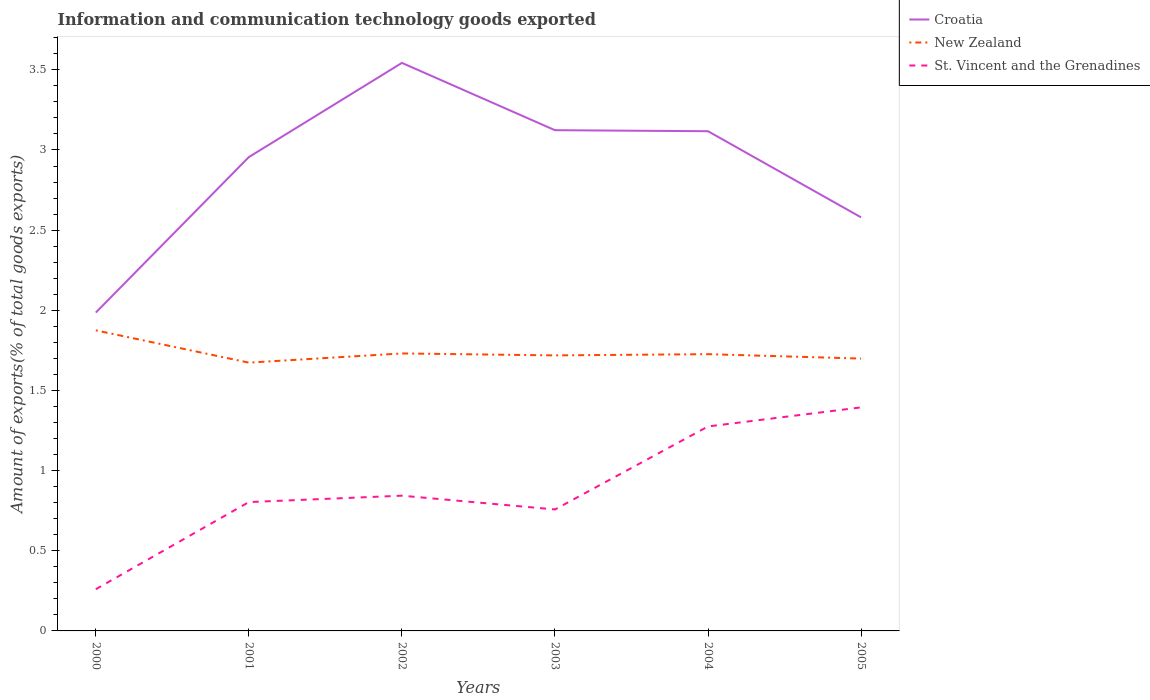How many different coloured lines are there?
Your response must be concise. 3. Is the number of lines equal to the number of legend labels?
Keep it short and to the point. Yes. Across all years, what is the maximum amount of goods exported in Croatia?
Provide a succinct answer. 1.99. In which year was the amount of goods exported in Croatia maximum?
Your response must be concise. 2000. What is the total amount of goods exported in New Zealand in the graph?
Your answer should be compact. 0.03. What is the difference between the highest and the second highest amount of goods exported in New Zealand?
Keep it short and to the point. 0.2. What is the difference between the highest and the lowest amount of goods exported in Croatia?
Give a very brief answer. 4. Is the amount of goods exported in St. Vincent and the Grenadines strictly greater than the amount of goods exported in New Zealand over the years?
Give a very brief answer. Yes. How many years are there in the graph?
Give a very brief answer. 6. Does the graph contain any zero values?
Your response must be concise. No. Does the graph contain grids?
Provide a succinct answer. No. Where does the legend appear in the graph?
Offer a terse response. Top right. How many legend labels are there?
Provide a succinct answer. 3. What is the title of the graph?
Your answer should be very brief. Information and communication technology goods exported. Does "Armenia" appear as one of the legend labels in the graph?
Your answer should be very brief. No. What is the label or title of the Y-axis?
Ensure brevity in your answer.  Amount of exports(% of total goods exports). What is the Amount of exports(% of total goods exports) in Croatia in 2000?
Your answer should be compact. 1.99. What is the Amount of exports(% of total goods exports) of New Zealand in 2000?
Give a very brief answer. 1.87. What is the Amount of exports(% of total goods exports) of St. Vincent and the Grenadines in 2000?
Offer a terse response. 0.26. What is the Amount of exports(% of total goods exports) in Croatia in 2001?
Your answer should be compact. 2.96. What is the Amount of exports(% of total goods exports) of New Zealand in 2001?
Provide a succinct answer. 1.67. What is the Amount of exports(% of total goods exports) in St. Vincent and the Grenadines in 2001?
Give a very brief answer. 0.8. What is the Amount of exports(% of total goods exports) in Croatia in 2002?
Offer a very short reply. 3.54. What is the Amount of exports(% of total goods exports) in New Zealand in 2002?
Ensure brevity in your answer.  1.73. What is the Amount of exports(% of total goods exports) in St. Vincent and the Grenadines in 2002?
Your response must be concise. 0.84. What is the Amount of exports(% of total goods exports) of Croatia in 2003?
Provide a succinct answer. 3.12. What is the Amount of exports(% of total goods exports) in New Zealand in 2003?
Make the answer very short. 1.72. What is the Amount of exports(% of total goods exports) of St. Vincent and the Grenadines in 2003?
Provide a succinct answer. 0.76. What is the Amount of exports(% of total goods exports) of Croatia in 2004?
Ensure brevity in your answer.  3.12. What is the Amount of exports(% of total goods exports) in New Zealand in 2004?
Ensure brevity in your answer.  1.73. What is the Amount of exports(% of total goods exports) in St. Vincent and the Grenadines in 2004?
Make the answer very short. 1.28. What is the Amount of exports(% of total goods exports) in Croatia in 2005?
Your answer should be compact. 2.58. What is the Amount of exports(% of total goods exports) of New Zealand in 2005?
Your answer should be compact. 1.7. What is the Amount of exports(% of total goods exports) of St. Vincent and the Grenadines in 2005?
Your answer should be compact. 1.39. Across all years, what is the maximum Amount of exports(% of total goods exports) of Croatia?
Keep it short and to the point. 3.54. Across all years, what is the maximum Amount of exports(% of total goods exports) of New Zealand?
Your response must be concise. 1.87. Across all years, what is the maximum Amount of exports(% of total goods exports) in St. Vincent and the Grenadines?
Give a very brief answer. 1.39. Across all years, what is the minimum Amount of exports(% of total goods exports) of Croatia?
Your response must be concise. 1.99. Across all years, what is the minimum Amount of exports(% of total goods exports) of New Zealand?
Offer a terse response. 1.67. Across all years, what is the minimum Amount of exports(% of total goods exports) of St. Vincent and the Grenadines?
Your answer should be compact. 0.26. What is the total Amount of exports(% of total goods exports) in Croatia in the graph?
Offer a very short reply. 17.31. What is the total Amount of exports(% of total goods exports) of New Zealand in the graph?
Ensure brevity in your answer.  10.42. What is the total Amount of exports(% of total goods exports) in St. Vincent and the Grenadines in the graph?
Offer a very short reply. 5.34. What is the difference between the Amount of exports(% of total goods exports) in Croatia in 2000 and that in 2001?
Keep it short and to the point. -0.97. What is the difference between the Amount of exports(% of total goods exports) of New Zealand in 2000 and that in 2001?
Provide a short and direct response. 0.2. What is the difference between the Amount of exports(% of total goods exports) in St. Vincent and the Grenadines in 2000 and that in 2001?
Make the answer very short. -0.54. What is the difference between the Amount of exports(% of total goods exports) in Croatia in 2000 and that in 2002?
Your response must be concise. -1.56. What is the difference between the Amount of exports(% of total goods exports) in New Zealand in 2000 and that in 2002?
Keep it short and to the point. 0.14. What is the difference between the Amount of exports(% of total goods exports) of St. Vincent and the Grenadines in 2000 and that in 2002?
Provide a succinct answer. -0.58. What is the difference between the Amount of exports(% of total goods exports) of Croatia in 2000 and that in 2003?
Ensure brevity in your answer.  -1.14. What is the difference between the Amount of exports(% of total goods exports) in New Zealand in 2000 and that in 2003?
Provide a succinct answer. 0.16. What is the difference between the Amount of exports(% of total goods exports) of St. Vincent and the Grenadines in 2000 and that in 2003?
Offer a terse response. -0.5. What is the difference between the Amount of exports(% of total goods exports) in Croatia in 2000 and that in 2004?
Provide a short and direct response. -1.13. What is the difference between the Amount of exports(% of total goods exports) of New Zealand in 2000 and that in 2004?
Offer a very short reply. 0.15. What is the difference between the Amount of exports(% of total goods exports) in St. Vincent and the Grenadines in 2000 and that in 2004?
Give a very brief answer. -1.02. What is the difference between the Amount of exports(% of total goods exports) of Croatia in 2000 and that in 2005?
Keep it short and to the point. -0.59. What is the difference between the Amount of exports(% of total goods exports) of New Zealand in 2000 and that in 2005?
Keep it short and to the point. 0.18. What is the difference between the Amount of exports(% of total goods exports) of St. Vincent and the Grenadines in 2000 and that in 2005?
Your response must be concise. -1.13. What is the difference between the Amount of exports(% of total goods exports) in Croatia in 2001 and that in 2002?
Ensure brevity in your answer.  -0.59. What is the difference between the Amount of exports(% of total goods exports) of New Zealand in 2001 and that in 2002?
Give a very brief answer. -0.06. What is the difference between the Amount of exports(% of total goods exports) of St. Vincent and the Grenadines in 2001 and that in 2002?
Offer a terse response. -0.04. What is the difference between the Amount of exports(% of total goods exports) of Croatia in 2001 and that in 2003?
Provide a succinct answer. -0.17. What is the difference between the Amount of exports(% of total goods exports) in New Zealand in 2001 and that in 2003?
Keep it short and to the point. -0.05. What is the difference between the Amount of exports(% of total goods exports) of St. Vincent and the Grenadines in 2001 and that in 2003?
Offer a very short reply. 0.05. What is the difference between the Amount of exports(% of total goods exports) in Croatia in 2001 and that in 2004?
Your response must be concise. -0.16. What is the difference between the Amount of exports(% of total goods exports) in New Zealand in 2001 and that in 2004?
Give a very brief answer. -0.05. What is the difference between the Amount of exports(% of total goods exports) of St. Vincent and the Grenadines in 2001 and that in 2004?
Ensure brevity in your answer.  -0.47. What is the difference between the Amount of exports(% of total goods exports) of Croatia in 2001 and that in 2005?
Ensure brevity in your answer.  0.38. What is the difference between the Amount of exports(% of total goods exports) in New Zealand in 2001 and that in 2005?
Keep it short and to the point. -0.03. What is the difference between the Amount of exports(% of total goods exports) of St. Vincent and the Grenadines in 2001 and that in 2005?
Give a very brief answer. -0.59. What is the difference between the Amount of exports(% of total goods exports) in Croatia in 2002 and that in 2003?
Provide a succinct answer. 0.42. What is the difference between the Amount of exports(% of total goods exports) in New Zealand in 2002 and that in 2003?
Your answer should be compact. 0.01. What is the difference between the Amount of exports(% of total goods exports) in St. Vincent and the Grenadines in 2002 and that in 2003?
Your response must be concise. 0.09. What is the difference between the Amount of exports(% of total goods exports) of Croatia in 2002 and that in 2004?
Offer a terse response. 0.43. What is the difference between the Amount of exports(% of total goods exports) of New Zealand in 2002 and that in 2004?
Your answer should be very brief. 0. What is the difference between the Amount of exports(% of total goods exports) of St. Vincent and the Grenadines in 2002 and that in 2004?
Provide a succinct answer. -0.43. What is the difference between the Amount of exports(% of total goods exports) in Croatia in 2002 and that in 2005?
Your response must be concise. 0.96. What is the difference between the Amount of exports(% of total goods exports) in New Zealand in 2002 and that in 2005?
Make the answer very short. 0.03. What is the difference between the Amount of exports(% of total goods exports) of St. Vincent and the Grenadines in 2002 and that in 2005?
Ensure brevity in your answer.  -0.55. What is the difference between the Amount of exports(% of total goods exports) of Croatia in 2003 and that in 2004?
Offer a very short reply. 0.01. What is the difference between the Amount of exports(% of total goods exports) of New Zealand in 2003 and that in 2004?
Give a very brief answer. -0.01. What is the difference between the Amount of exports(% of total goods exports) of St. Vincent and the Grenadines in 2003 and that in 2004?
Give a very brief answer. -0.52. What is the difference between the Amount of exports(% of total goods exports) in Croatia in 2003 and that in 2005?
Make the answer very short. 0.54. What is the difference between the Amount of exports(% of total goods exports) in New Zealand in 2003 and that in 2005?
Offer a very short reply. 0.02. What is the difference between the Amount of exports(% of total goods exports) in St. Vincent and the Grenadines in 2003 and that in 2005?
Keep it short and to the point. -0.64. What is the difference between the Amount of exports(% of total goods exports) of Croatia in 2004 and that in 2005?
Your answer should be compact. 0.54. What is the difference between the Amount of exports(% of total goods exports) in New Zealand in 2004 and that in 2005?
Offer a terse response. 0.03. What is the difference between the Amount of exports(% of total goods exports) of St. Vincent and the Grenadines in 2004 and that in 2005?
Make the answer very short. -0.12. What is the difference between the Amount of exports(% of total goods exports) in Croatia in 2000 and the Amount of exports(% of total goods exports) in New Zealand in 2001?
Offer a terse response. 0.31. What is the difference between the Amount of exports(% of total goods exports) in Croatia in 2000 and the Amount of exports(% of total goods exports) in St. Vincent and the Grenadines in 2001?
Give a very brief answer. 1.18. What is the difference between the Amount of exports(% of total goods exports) in New Zealand in 2000 and the Amount of exports(% of total goods exports) in St. Vincent and the Grenadines in 2001?
Offer a very short reply. 1.07. What is the difference between the Amount of exports(% of total goods exports) in Croatia in 2000 and the Amount of exports(% of total goods exports) in New Zealand in 2002?
Give a very brief answer. 0.25. What is the difference between the Amount of exports(% of total goods exports) of Croatia in 2000 and the Amount of exports(% of total goods exports) of St. Vincent and the Grenadines in 2002?
Make the answer very short. 1.14. What is the difference between the Amount of exports(% of total goods exports) of New Zealand in 2000 and the Amount of exports(% of total goods exports) of St. Vincent and the Grenadines in 2002?
Ensure brevity in your answer.  1.03. What is the difference between the Amount of exports(% of total goods exports) of Croatia in 2000 and the Amount of exports(% of total goods exports) of New Zealand in 2003?
Your answer should be compact. 0.27. What is the difference between the Amount of exports(% of total goods exports) of Croatia in 2000 and the Amount of exports(% of total goods exports) of St. Vincent and the Grenadines in 2003?
Keep it short and to the point. 1.23. What is the difference between the Amount of exports(% of total goods exports) in New Zealand in 2000 and the Amount of exports(% of total goods exports) in St. Vincent and the Grenadines in 2003?
Keep it short and to the point. 1.12. What is the difference between the Amount of exports(% of total goods exports) of Croatia in 2000 and the Amount of exports(% of total goods exports) of New Zealand in 2004?
Give a very brief answer. 0.26. What is the difference between the Amount of exports(% of total goods exports) of Croatia in 2000 and the Amount of exports(% of total goods exports) of St. Vincent and the Grenadines in 2004?
Ensure brevity in your answer.  0.71. What is the difference between the Amount of exports(% of total goods exports) in New Zealand in 2000 and the Amount of exports(% of total goods exports) in St. Vincent and the Grenadines in 2004?
Your response must be concise. 0.6. What is the difference between the Amount of exports(% of total goods exports) of Croatia in 2000 and the Amount of exports(% of total goods exports) of New Zealand in 2005?
Offer a terse response. 0.29. What is the difference between the Amount of exports(% of total goods exports) of Croatia in 2000 and the Amount of exports(% of total goods exports) of St. Vincent and the Grenadines in 2005?
Keep it short and to the point. 0.59. What is the difference between the Amount of exports(% of total goods exports) in New Zealand in 2000 and the Amount of exports(% of total goods exports) in St. Vincent and the Grenadines in 2005?
Provide a short and direct response. 0.48. What is the difference between the Amount of exports(% of total goods exports) in Croatia in 2001 and the Amount of exports(% of total goods exports) in New Zealand in 2002?
Your answer should be very brief. 1.22. What is the difference between the Amount of exports(% of total goods exports) of Croatia in 2001 and the Amount of exports(% of total goods exports) of St. Vincent and the Grenadines in 2002?
Your answer should be very brief. 2.11. What is the difference between the Amount of exports(% of total goods exports) in New Zealand in 2001 and the Amount of exports(% of total goods exports) in St. Vincent and the Grenadines in 2002?
Your answer should be compact. 0.83. What is the difference between the Amount of exports(% of total goods exports) of Croatia in 2001 and the Amount of exports(% of total goods exports) of New Zealand in 2003?
Provide a succinct answer. 1.24. What is the difference between the Amount of exports(% of total goods exports) of Croatia in 2001 and the Amount of exports(% of total goods exports) of St. Vincent and the Grenadines in 2003?
Provide a short and direct response. 2.2. What is the difference between the Amount of exports(% of total goods exports) in New Zealand in 2001 and the Amount of exports(% of total goods exports) in St. Vincent and the Grenadines in 2003?
Make the answer very short. 0.92. What is the difference between the Amount of exports(% of total goods exports) of Croatia in 2001 and the Amount of exports(% of total goods exports) of New Zealand in 2004?
Your answer should be compact. 1.23. What is the difference between the Amount of exports(% of total goods exports) in Croatia in 2001 and the Amount of exports(% of total goods exports) in St. Vincent and the Grenadines in 2004?
Keep it short and to the point. 1.68. What is the difference between the Amount of exports(% of total goods exports) in New Zealand in 2001 and the Amount of exports(% of total goods exports) in St. Vincent and the Grenadines in 2004?
Keep it short and to the point. 0.4. What is the difference between the Amount of exports(% of total goods exports) of Croatia in 2001 and the Amount of exports(% of total goods exports) of New Zealand in 2005?
Offer a very short reply. 1.26. What is the difference between the Amount of exports(% of total goods exports) of Croatia in 2001 and the Amount of exports(% of total goods exports) of St. Vincent and the Grenadines in 2005?
Provide a short and direct response. 1.56. What is the difference between the Amount of exports(% of total goods exports) in New Zealand in 2001 and the Amount of exports(% of total goods exports) in St. Vincent and the Grenadines in 2005?
Your response must be concise. 0.28. What is the difference between the Amount of exports(% of total goods exports) in Croatia in 2002 and the Amount of exports(% of total goods exports) in New Zealand in 2003?
Your answer should be compact. 1.82. What is the difference between the Amount of exports(% of total goods exports) of Croatia in 2002 and the Amount of exports(% of total goods exports) of St. Vincent and the Grenadines in 2003?
Your response must be concise. 2.79. What is the difference between the Amount of exports(% of total goods exports) in New Zealand in 2002 and the Amount of exports(% of total goods exports) in St. Vincent and the Grenadines in 2003?
Your answer should be compact. 0.97. What is the difference between the Amount of exports(% of total goods exports) in Croatia in 2002 and the Amount of exports(% of total goods exports) in New Zealand in 2004?
Give a very brief answer. 1.82. What is the difference between the Amount of exports(% of total goods exports) in Croatia in 2002 and the Amount of exports(% of total goods exports) in St. Vincent and the Grenadines in 2004?
Provide a succinct answer. 2.27. What is the difference between the Amount of exports(% of total goods exports) in New Zealand in 2002 and the Amount of exports(% of total goods exports) in St. Vincent and the Grenadines in 2004?
Your answer should be compact. 0.46. What is the difference between the Amount of exports(% of total goods exports) of Croatia in 2002 and the Amount of exports(% of total goods exports) of New Zealand in 2005?
Provide a short and direct response. 1.84. What is the difference between the Amount of exports(% of total goods exports) in Croatia in 2002 and the Amount of exports(% of total goods exports) in St. Vincent and the Grenadines in 2005?
Your response must be concise. 2.15. What is the difference between the Amount of exports(% of total goods exports) in New Zealand in 2002 and the Amount of exports(% of total goods exports) in St. Vincent and the Grenadines in 2005?
Offer a terse response. 0.34. What is the difference between the Amount of exports(% of total goods exports) in Croatia in 2003 and the Amount of exports(% of total goods exports) in New Zealand in 2004?
Keep it short and to the point. 1.4. What is the difference between the Amount of exports(% of total goods exports) of Croatia in 2003 and the Amount of exports(% of total goods exports) of St. Vincent and the Grenadines in 2004?
Keep it short and to the point. 1.85. What is the difference between the Amount of exports(% of total goods exports) of New Zealand in 2003 and the Amount of exports(% of total goods exports) of St. Vincent and the Grenadines in 2004?
Make the answer very short. 0.44. What is the difference between the Amount of exports(% of total goods exports) in Croatia in 2003 and the Amount of exports(% of total goods exports) in New Zealand in 2005?
Keep it short and to the point. 1.42. What is the difference between the Amount of exports(% of total goods exports) in Croatia in 2003 and the Amount of exports(% of total goods exports) in St. Vincent and the Grenadines in 2005?
Make the answer very short. 1.73. What is the difference between the Amount of exports(% of total goods exports) in New Zealand in 2003 and the Amount of exports(% of total goods exports) in St. Vincent and the Grenadines in 2005?
Make the answer very short. 0.32. What is the difference between the Amount of exports(% of total goods exports) of Croatia in 2004 and the Amount of exports(% of total goods exports) of New Zealand in 2005?
Ensure brevity in your answer.  1.42. What is the difference between the Amount of exports(% of total goods exports) of Croatia in 2004 and the Amount of exports(% of total goods exports) of St. Vincent and the Grenadines in 2005?
Your answer should be compact. 1.72. What is the difference between the Amount of exports(% of total goods exports) of New Zealand in 2004 and the Amount of exports(% of total goods exports) of St. Vincent and the Grenadines in 2005?
Your response must be concise. 0.33. What is the average Amount of exports(% of total goods exports) in Croatia per year?
Make the answer very short. 2.88. What is the average Amount of exports(% of total goods exports) of New Zealand per year?
Make the answer very short. 1.74. What is the average Amount of exports(% of total goods exports) of St. Vincent and the Grenadines per year?
Provide a succinct answer. 0.89. In the year 2000, what is the difference between the Amount of exports(% of total goods exports) in Croatia and Amount of exports(% of total goods exports) in New Zealand?
Provide a succinct answer. 0.11. In the year 2000, what is the difference between the Amount of exports(% of total goods exports) in Croatia and Amount of exports(% of total goods exports) in St. Vincent and the Grenadines?
Provide a succinct answer. 1.73. In the year 2000, what is the difference between the Amount of exports(% of total goods exports) of New Zealand and Amount of exports(% of total goods exports) of St. Vincent and the Grenadines?
Give a very brief answer. 1.61. In the year 2001, what is the difference between the Amount of exports(% of total goods exports) in Croatia and Amount of exports(% of total goods exports) in New Zealand?
Give a very brief answer. 1.28. In the year 2001, what is the difference between the Amount of exports(% of total goods exports) in Croatia and Amount of exports(% of total goods exports) in St. Vincent and the Grenadines?
Ensure brevity in your answer.  2.15. In the year 2001, what is the difference between the Amount of exports(% of total goods exports) in New Zealand and Amount of exports(% of total goods exports) in St. Vincent and the Grenadines?
Provide a succinct answer. 0.87. In the year 2002, what is the difference between the Amount of exports(% of total goods exports) in Croatia and Amount of exports(% of total goods exports) in New Zealand?
Provide a short and direct response. 1.81. In the year 2002, what is the difference between the Amount of exports(% of total goods exports) in Croatia and Amount of exports(% of total goods exports) in St. Vincent and the Grenadines?
Keep it short and to the point. 2.7. In the year 2002, what is the difference between the Amount of exports(% of total goods exports) of New Zealand and Amount of exports(% of total goods exports) of St. Vincent and the Grenadines?
Your response must be concise. 0.89. In the year 2003, what is the difference between the Amount of exports(% of total goods exports) in Croatia and Amount of exports(% of total goods exports) in New Zealand?
Give a very brief answer. 1.4. In the year 2003, what is the difference between the Amount of exports(% of total goods exports) of Croatia and Amount of exports(% of total goods exports) of St. Vincent and the Grenadines?
Offer a terse response. 2.37. In the year 2004, what is the difference between the Amount of exports(% of total goods exports) in Croatia and Amount of exports(% of total goods exports) in New Zealand?
Keep it short and to the point. 1.39. In the year 2004, what is the difference between the Amount of exports(% of total goods exports) of Croatia and Amount of exports(% of total goods exports) of St. Vincent and the Grenadines?
Offer a very short reply. 1.84. In the year 2004, what is the difference between the Amount of exports(% of total goods exports) of New Zealand and Amount of exports(% of total goods exports) of St. Vincent and the Grenadines?
Your answer should be very brief. 0.45. In the year 2005, what is the difference between the Amount of exports(% of total goods exports) in Croatia and Amount of exports(% of total goods exports) in New Zealand?
Provide a short and direct response. 0.88. In the year 2005, what is the difference between the Amount of exports(% of total goods exports) in Croatia and Amount of exports(% of total goods exports) in St. Vincent and the Grenadines?
Your response must be concise. 1.19. In the year 2005, what is the difference between the Amount of exports(% of total goods exports) in New Zealand and Amount of exports(% of total goods exports) in St. Vincent and the Grenadines?
Your answer should be compact. 0.3. What is the ratio of the Amount of exports(% of total goods exports) in Croatia in 2000 to that in 2001?
Your answer should be compact. 0.67. What is the ratio of the Amount of exports(% of total goods exports) in New Zealand in 2000 to that in 2001?
Keep it short and to the point. 1.12. What is the ratio of the Amount of exports(% of total goods exports) of St. Vincent and the Grenadines in 2000 to that in 2001?
Keep it short and to the point. 0.32. What is the ratio of the Amount of exports(% of total goods exports) of Croatia in 2000 to that in 2002?
Offer a terse response. 0.56. What is the ratio of the Amount of exports(% of total goods exports) in New Zealand in 2000 to that in 2002?
Give a very brief answer. 1.08. What is the ratio of the Amount of exports(% of total goods exports) of St. Vincent and the Grenadines in 2000 to that in 2002?
Make the answer very short. 0.31. What is the ratio of the Amount of exports(% of total goods exports) of Croatia in 2000 to that in 2003?
Your response must be concise. 0.64. What is the ratio of the Amount of exports(% of total goods exports) in St. Vincent and the Grenadines in 2000 to that in 2003?
Keep it short and to the point. 0.34. What is the ratio of the Amount of exports(% of total goods exports) of Croatia in 2000 to that in 2004?
Your answer should be compact. 0.64. What is the ratio of the Amount of exports(% of total goods exports) of New Zealand in 2000 to that in 2004?
Your response must be concise. 1.09. What is the ratio of the Amount of exports(% of total goods exports) in St. Vincent and the Grenadines in 2000 to that in 2004?
Keep it short and to the point. 0.2. What is the ratio of the Amount of exports(% of total goods exports) in Croatia in 2000 to that in 2005?
Keep it short and to the point. 0.77. What is the ratio of the Amount of exports(% of total goods exports) in New Zealand in 2000 to that in 2005?
Your answer should be very brief. 1.1. What is the ratio of the Amount of exports(% of total goods exports) in St. Vincent and the Grenadines in 2000 to that in 2005?
Your answer should be very brief. 0.19. What is the ratio of the Amount of exports(% of total goods exports) in Croatia in 2001 to that in 2002?
Provide a short and direct response. 0.83. What is the ratio of the Amount of exports(% of total goods exports) in New Zealand in 2001 to that in 2002?
Ensure brevity in your answer.  0.97. What is the ratio of the Amount of exports(% of total goods exports) of St. Vincent and the Grenadines in 2001 to that in 2002?
Your response must be concise. 0.95. What is the ratio of the Amount of exports(% of total goods exports) in Croatia in 2001 to that in 2003?
Your response must be concise. 0.95. What is the ratio of the Amount of exports(% of total goods exports) of New Zealand in 2001 to that in 2003?
Offer a terse response. 0.97. What is the ratio of the Amount of exports(% of total goods exports) in St. Vincent and the Grenadines in 2001 to that in 2003?
Your answer should be compact. 1.06. What is the ratio of the Amount of exports(% of total goods exports) of Croatia in 2001 to that in 2004?
Your response must be concise. 0.95. What is the ratio of the Amount of exports(% of total goods exports) of New Zealand in 2001 to that in 2004?
Provide a short and direct response. 0.97. What is the ratio of the Amount of exports(% of total goods exports) in St. Vincent and the Grenadines in 2001 to that in 2004?
Offer a terse response. 0.63. What is the ratio of the Amount of exports(% of total goods exports) in Croatia in 2001 to that in 2005?
Offer a very short reply. 1.15. What is the ratio of the Amount of exports(% of total goods exports) of New Zealand in 2001 to that in 2005?
Give a very brief answer. 0.99. What is the ratio of the Amount of exports(% of total goods exports) in St. Vincent and the Grenadines in 2001 to that in 2005?
Your answer should be compact. 0.58. What is the ratio of the Amount of exports(% of total goods exports) in Croatia in 2002 to that in 2003?
Keep it short and to the point. 1.13. What is the ratio of the Amount of exports(% of total goods exports) of New Zealand in 2002 to that in 2003?
Offer a terse response. 1.01. What is the ratio of the Amount of exports(% of total goods exports) in St. Vincent and the Grenadines in 2002 to that in 2003?
Provide a short and direct response. 1.11. What is the ratio of the Amount of exports(% of total goods exports) in Croatia in 2002 to that in 2004?
Give a very brief answer. 1.14. What is the ratio of the Amount of exports(% of total goods exports) of St. Vincent and the Grenadines in 2002 to that in 2004?
Offer a very short reply. 0.66. What is the ratio of the Amount of exports(% of total goods exports) of Croatia in 2002 to that in 2005?
Give a very brief answer. 1.37. What is the ratio of the Amount of exports(% of total goods exports) of New Zealand in 2002 to that in 2005?
Keep it short and to the point. 1.02. What is the ratio of the Amount of exports(% of total goods exports) of St. Vincent and the Grenadines in 2002 to that in 2005?
Provide a succinct answer. 0.6. What is the ratio of the Amount of exports(% of total goods exports) of St. Vincent and the Grenadines in 2003 to that in 2004?
Give a very brief answer. 0.59. What is the ratio of the Amount of exports(% of total goods exports) of Croatia in 2003 to that in 2005?
Offer a terse response. 1.21. What is the ratio of the Amount of exports(% of total goods exports) of New Zealand in 2003 to that in 2005?
Provide a short and direct response. 1.01. What is the ratio of the Amount of exports(% of total goods exports) in St. Vincent and the Grenadines in 2003 to that in 2005?
Your answer should be very brief. 0.54. What is the ratio of the Amount of exports(% of total goods exports) of Croatia in 2004 to that in 2005?
Make the answer very short. 1.21. What is the ratio of the Amount of exports(% of total goods exports) in New Zealand in 2004 to that in 2005?
Offer a terse response. 1.02. What is the ratio of the Amount of exports(% of total goods exports) of St. Vincent and the Grenadines in 2004 to that in 2005?
Keep it short and to the point. 0.91. What is the difference between the highest and the second highest Amount of exports(% of total goods exports) in Croatia?
Offer a very short reply. 0.42. What is the difference between the highest and the second highest Amount of exports(% of total goods exports) of New Zealand?
Give a very brief answer. 0.14. What is the difference between the highest and the second highest Amount of exports(% of total goods exports) of St. Vincent and the Grenadines?
Offer a very short reply. 0.12. What is the difference between the highest and the lowest Amount of exports(% of total goods exports) of Croatia?
Give a very brief answer. 1.56. What is the difference between the highest and the lowest Amount of exports(% of total goods exports) of New Zealand?
Give a very brief answer. 0.2. What is the difference between the highest and the lowest Amount of exports(% of total goods exports) of St. Vincent and the Grenadines?
Provide a short and direct response. 1.13. 